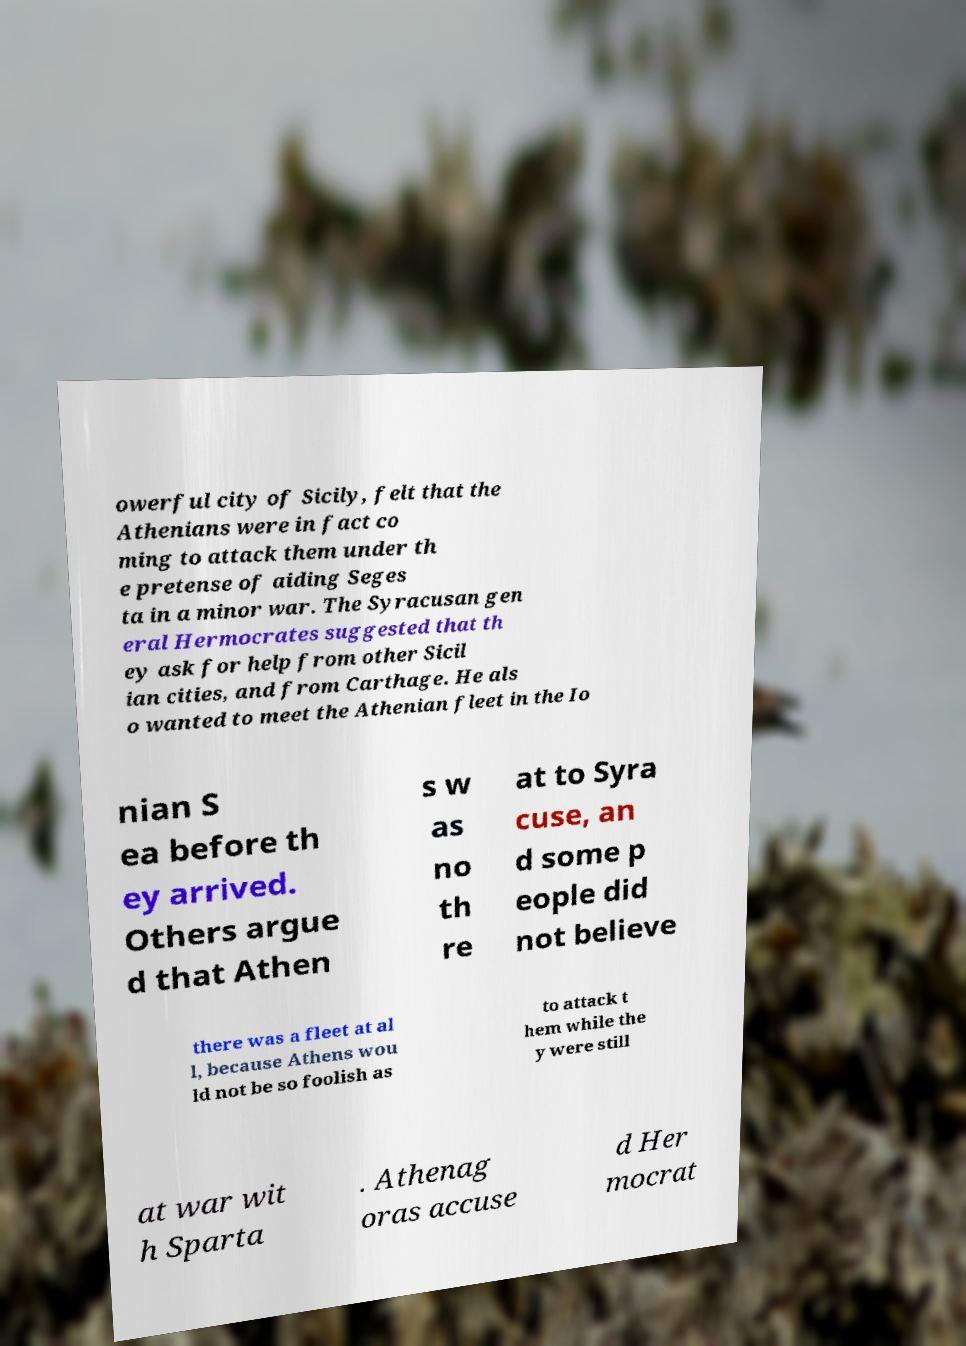What messages or text are displayed in this image? I need them in a readable, typed format. owerful city of Sicily, felt that the Athenians were in fact co ming to attack them under th e pretense of aiding Seges ta in a minor war. The Syracusan gen eral Hermocrates suggested that th ey ask for help from other Sicil ian cities, and from Carthage. He als o wanted to meet the Athenian fleet in the Io nian S ea before th ey arrived. Others argue d that Athen s w as no th re at to Syra cuse, an d some p eople did not believe there was a fleet at al l, because Athens wou ld not be so foolish as to attack t hem while the y were still at war wit h Sparta . Athenag oras accuse d Her mocrat 